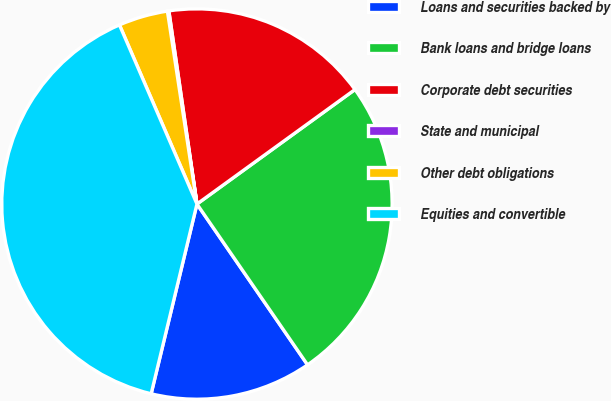Convert chart to OTSL. <chart><loc_0><loc_0><loc_500><loc_500><pie_chart><fcel>Loans and securities backed by<fcel>Bank loans and bridge loans<fcel>Corporate debt securities<fcel>State and municipal<fcel>Other debt obligations<fcel>Equities and convertible<nl><fcel>13.36%<fcel>25.39%<fcel>17.32%<fcel>0.12%<fcel>4.08%<fcel>39.73%<nl></chart> 